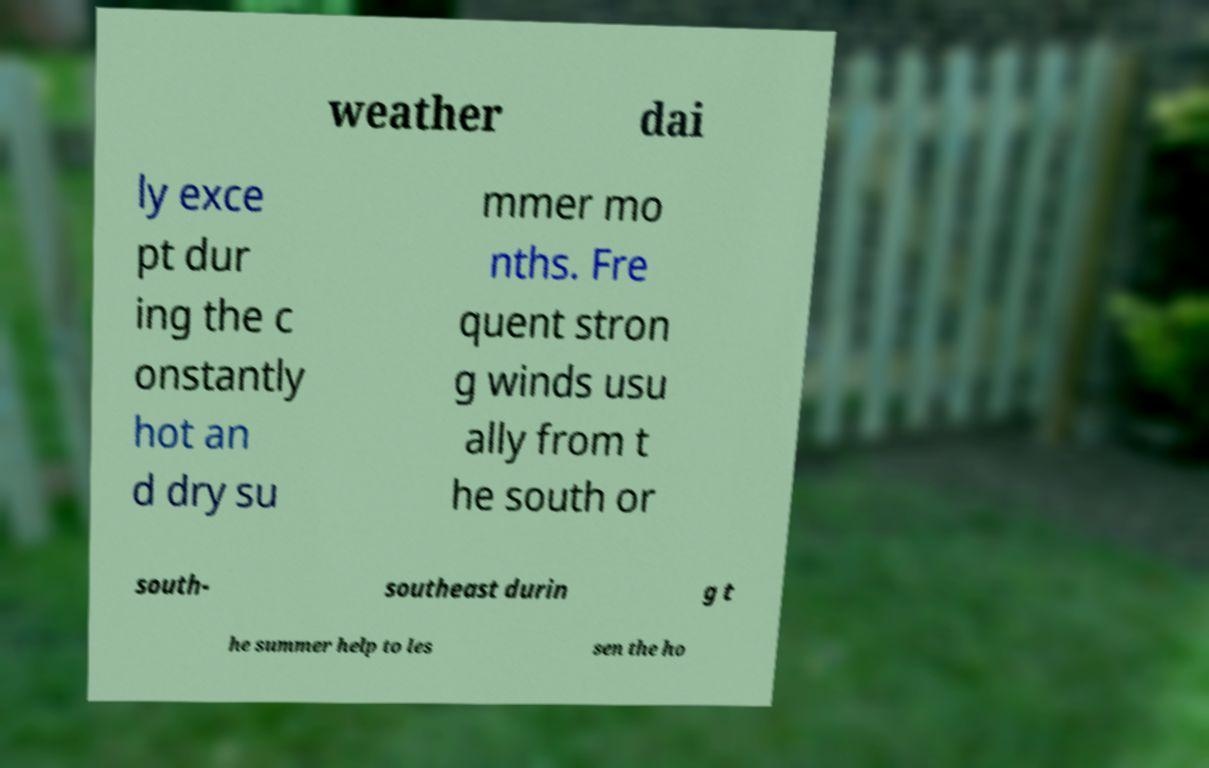Please identify and transcribe the text found in this image. weather dai ly exce pt dur ing the c onstantly hot an d dry su mmer mo nths. Fre quent stron g winds usu ally from t he south or south- southeast durin g t he summer help to les sen the ho 